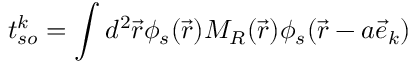Convert formula to latex. <formula><loc_0><loc_0><loc_500><loc_500>t _ { s o } ^ { k } = \int d ^ { 2 } \vec { r } \phi _ { s } ( \vec { r } ) M _ { R } ( \vec { r } ) \phi _ { s } ( \vec { r } - a \vec { e } _ { k } )</formula> 